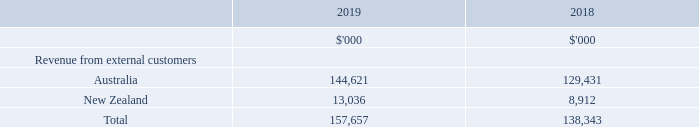4. SEGMENT INFORMATION
During the 2019 and 2018 financial years, the Group operated wholly within one business segment being the operation and management of storage centres in Australia and New Zealand.
The Managing Director is the Group’s chief operating decision maker and monitors the operating results on a portfolio wide basis. Monthly management reports are evaluated based upon the overall performance of NSR consistent with the presentation within the consolidated financial statements. The Group’s financing (including finance costs and finance income) are managed on a Group basis and not allocated to operating segments.
The operating results presented in the statement of profit or loss represent the same segment information as reported in internal management information.
The revenue information above excludes interest income and is based on the location of storage centres.
How many business segments were present in 2019 and 2018? One. How are the Group's financing managed? On a group basis and not allocated to operating segments. What were the revenues from Australia and New Zealand in 2019 respectively?
Answer scale should be: thousand. 144,621, 13,036. What is the change in the revenue from Australia from 2018 to 2019?
Answer scale should be: thousand. 144,621 - 129,431
Answer: 15190. What is the average revenue from New Zealand for 2018 and 2019?
Answer scale should be: thousand. (13,036 + 8,912) / 2
Answer: 10974. In which year was revenue from New Zealand under 10,000 thousands? Locate and analyze revenue from new zealand in row 5
answer: 2018. 